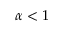<formula> <loc_0><loc_0><loc_500><loc_500>\alpha < 1</formula> 